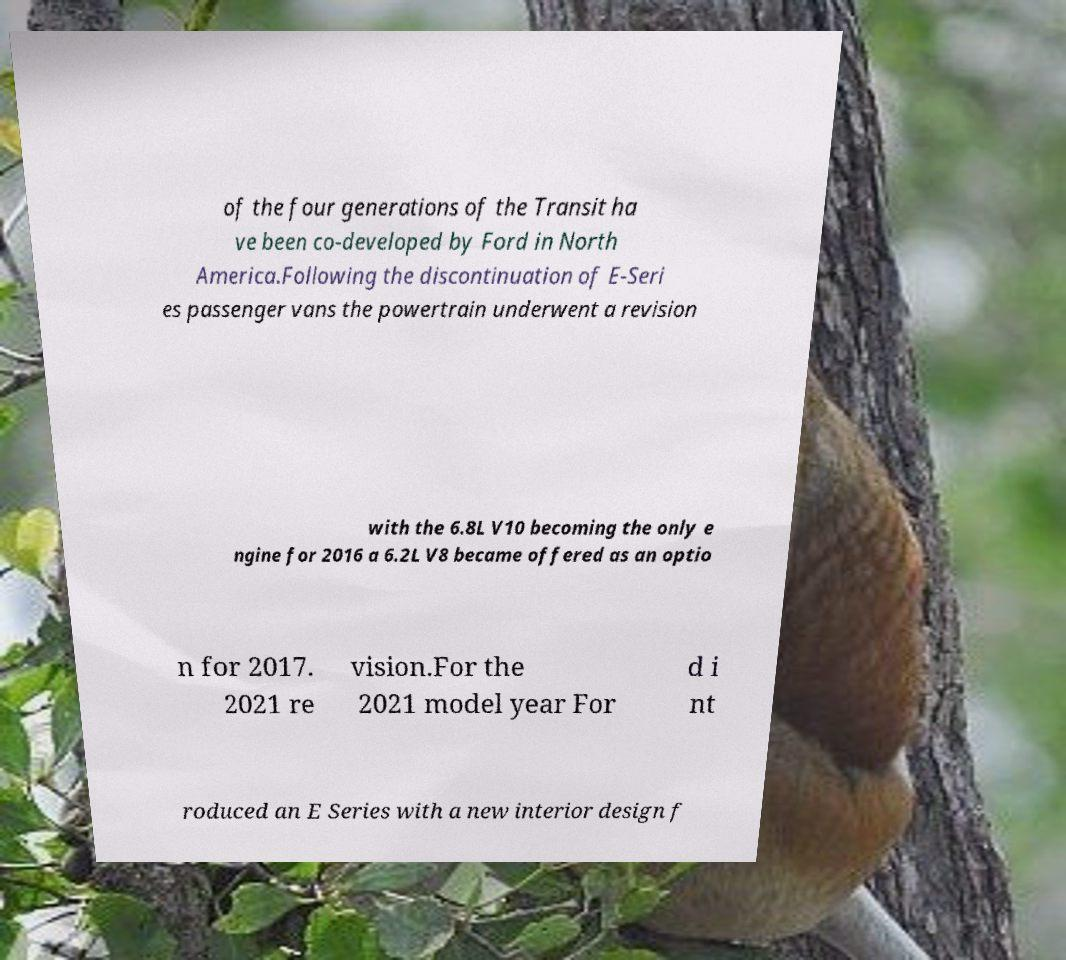Please identify and transcribe the text found in this image. of the four generations of the Transit ha ve been co-developed by Ford in North America.Following the discontinuation of E-Seri es passenger vans the powertrain underwent a revision with the 6.8L V10 becoming the only e ngine for 2016 a 6.2L V8 became offered as an optio n for 2017. 2021 re vision.For the 2021 model year For d i nt roduced an E Series with a new interior design f 